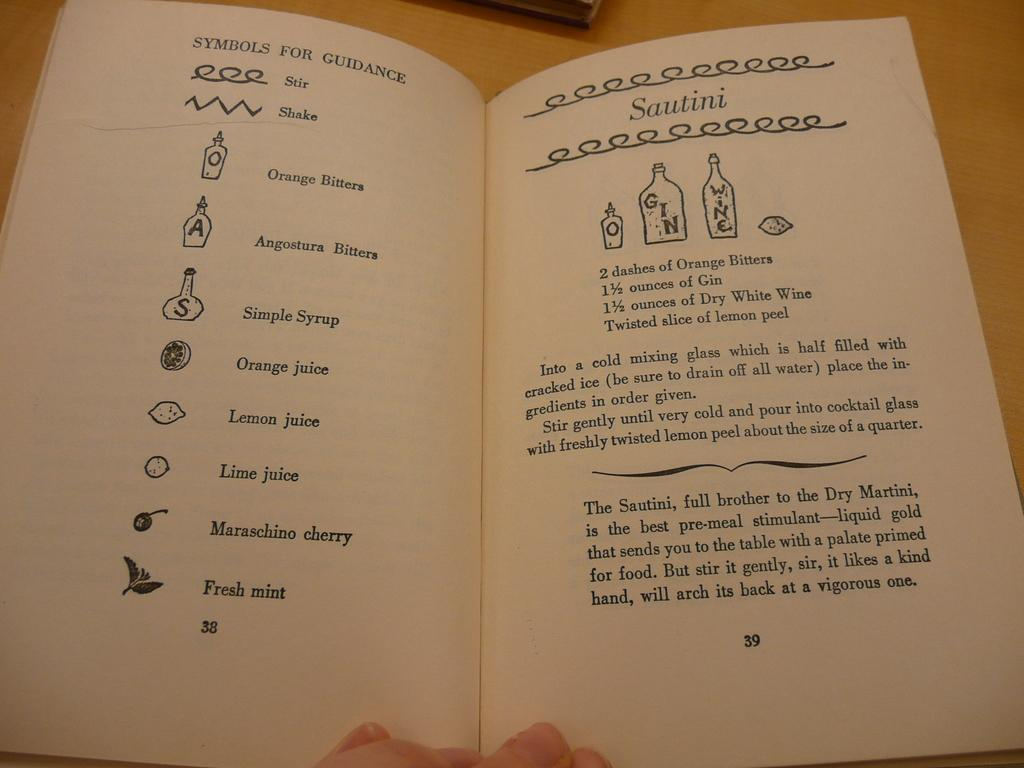<image>
Provide a brief description of the given image. A recipe book opened to a symbol guidance page and a recipe for Sautini. 